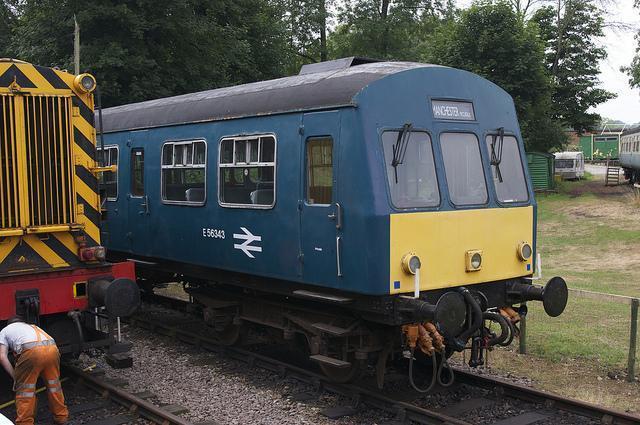How many trains can you see?
Give a very brief answer. 2. How many donuts are there?
Give a very brief answer. 0. 